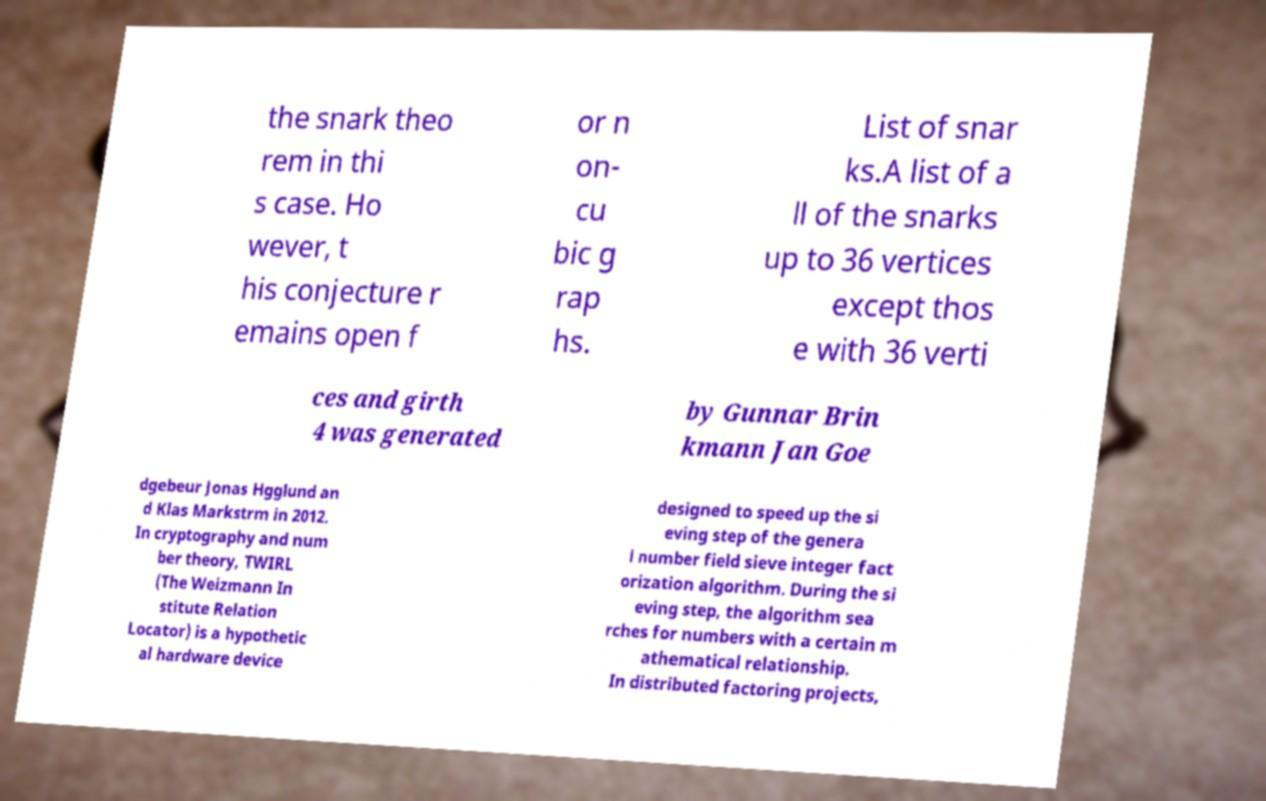There's text embedded in this image that I need extracted. Can you transcribe it verbatim? the snark theo rem in thi s case. Ho wever, t his conjecture r emains open f or n on- cu bic g rap hs. List of snar ks.A list of a ll of the snarks up to 36 vertices except thos e with 36 verti ces and girth 4 was generated by Gunnar Brin kmann Jan Goe dgebeur Jonas Hgglund an d Klas Markstrm in 2012. In cryptography and num ber theory, TWIRL (The Weizmann In stitute Relation Locator) is a hypothetic al hardware device designed to speed up the si eving step of the genera l number field sieve integer fact orization algorithm. During the si eving step, the algorithm sea rches for numbers with a certain m athematical relationship. In distributed factoring projects, 